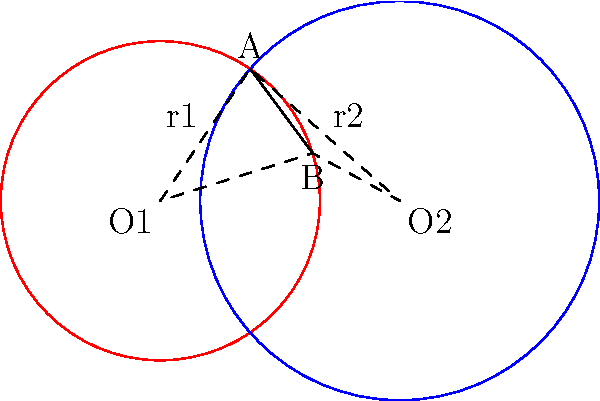In Luca Guadagnino's "Suspiria," Tilda Swinton plays dual roles that intersect in mysterious ways, much like the two circles in this diagram. If the distance between the centers of these circles (O1 and O2) is 3 units, the radius of the red circle (r1) is 2 units, and the radius of the blue circle (r2) is 2.5 units, what is the length of the common chord AB? Let's approach this step-by-step, inspired by the duality in Tilda Swinton's performance:

1) First, we need to recall the formula for the length of a common chord between two intersecting circles. If d is the distance between the centers, and r1 and r2 are the radii, then the length of the common chord (let's call it L) is given by:

   $$L = 2\sqrt{\frac{(r1+r2+d)(r1+r2-d)(r1-r2+d)(-r1+r2+d)}{4d^2}}$$

2) We are given:
   d = 3 (distance between O1 and O2)
   r1 = 2 (radius of the red circle)
   r2 = 2.5 (radius of the blue circle)

3) Let's substitute these values into our formula:

   $$L = 2\sqrt{\frac{(2+2.5+3)(2+2.5-3)(2-2.5+3)(-2+2.5+3)}{4(3^2)}}$$

4) Simplify inside the parentheses:

   $$L = 2\sqrt{\frac{(7.5)(1.5)(2.5)(3.5)}{36}}$$

5) Multiply the numbers inside the parentheses:

   $$L = 2\sqrt{\frac{98.4375}{36}}$$

6) Divide inside the square root:

   $$L = 2\sqrt{2.734375}$$

7) Take the square root:

   $$L = 2(1.65361...)$$

8) Multiply:

   $$L \approx 3.30722$$

Therefore, the length of the common chord AB is approximately 3.31 units.
Answer: 3.31 units 